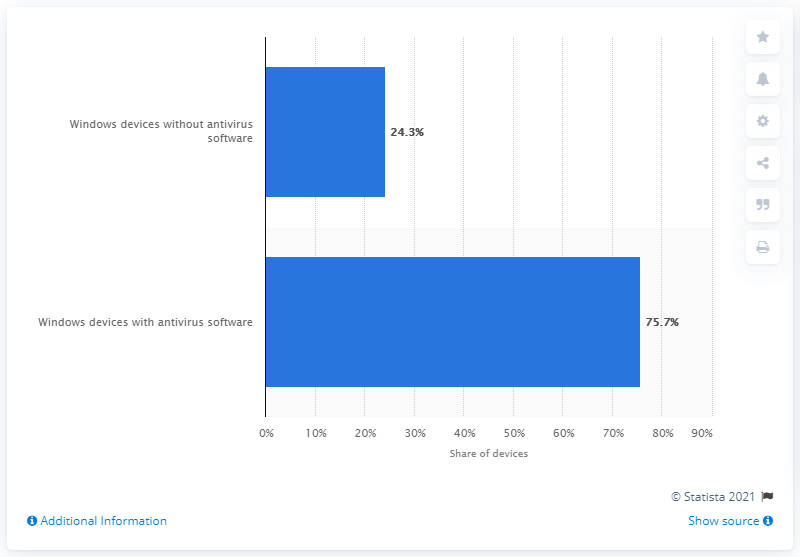Specify some key components in this picture. In May 2015, it was found that 75.7% of Windows devices worldwide were using antivirus software. 